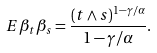Convert formula to latex. <formula><loc_0><loc_0><loc_500><loc_500>E \beta _ { t } \beta _ { s } = \frac { ( t \wedge s ) ^ { 1 - \gamma / \alpha } } { 1 - \gamma / \alpha } .</formula> 